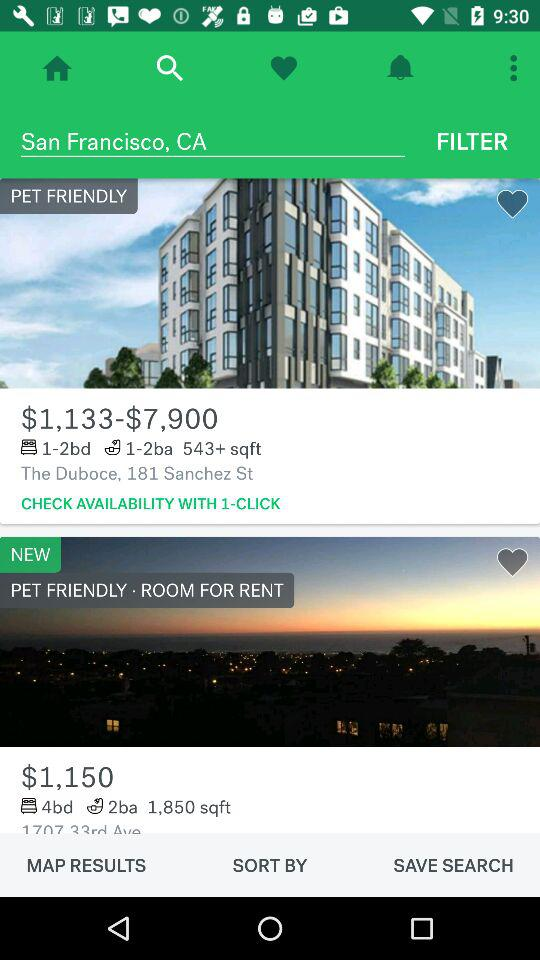What is the number of beds in the room located at "The Duboce", 181 Sanchez St.? In the room located in "The Duboce", 181 Sanchez St., there are 1 to 2 beds. 